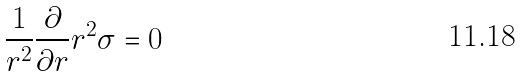Convert formula to latex. <formula><loc_0><loc_0><loc_500><loc_500>\frac { 1 } { r ^ { 2 } } \frac { \partial } { \partial r } r ^ { 2 } \sigma = 0</formula> 